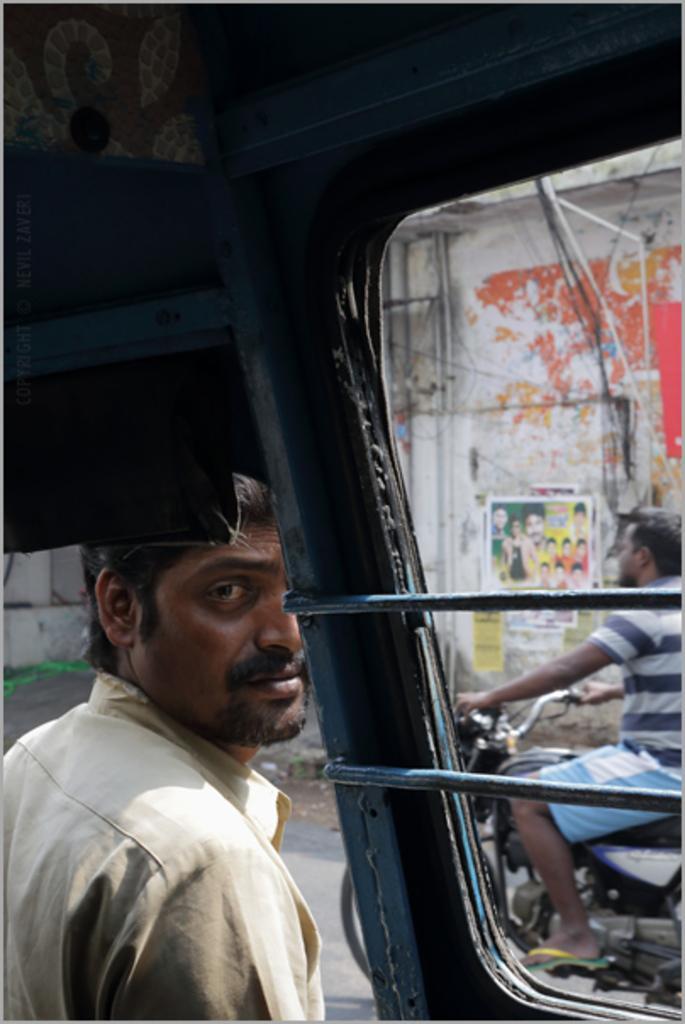Could you give a brief overview of what you see in this image? In this picture there is a person standing behind the vehicle and there is a person riding motor bike on the road. At the back there is a poster and there are wires, pipes on the wall. 